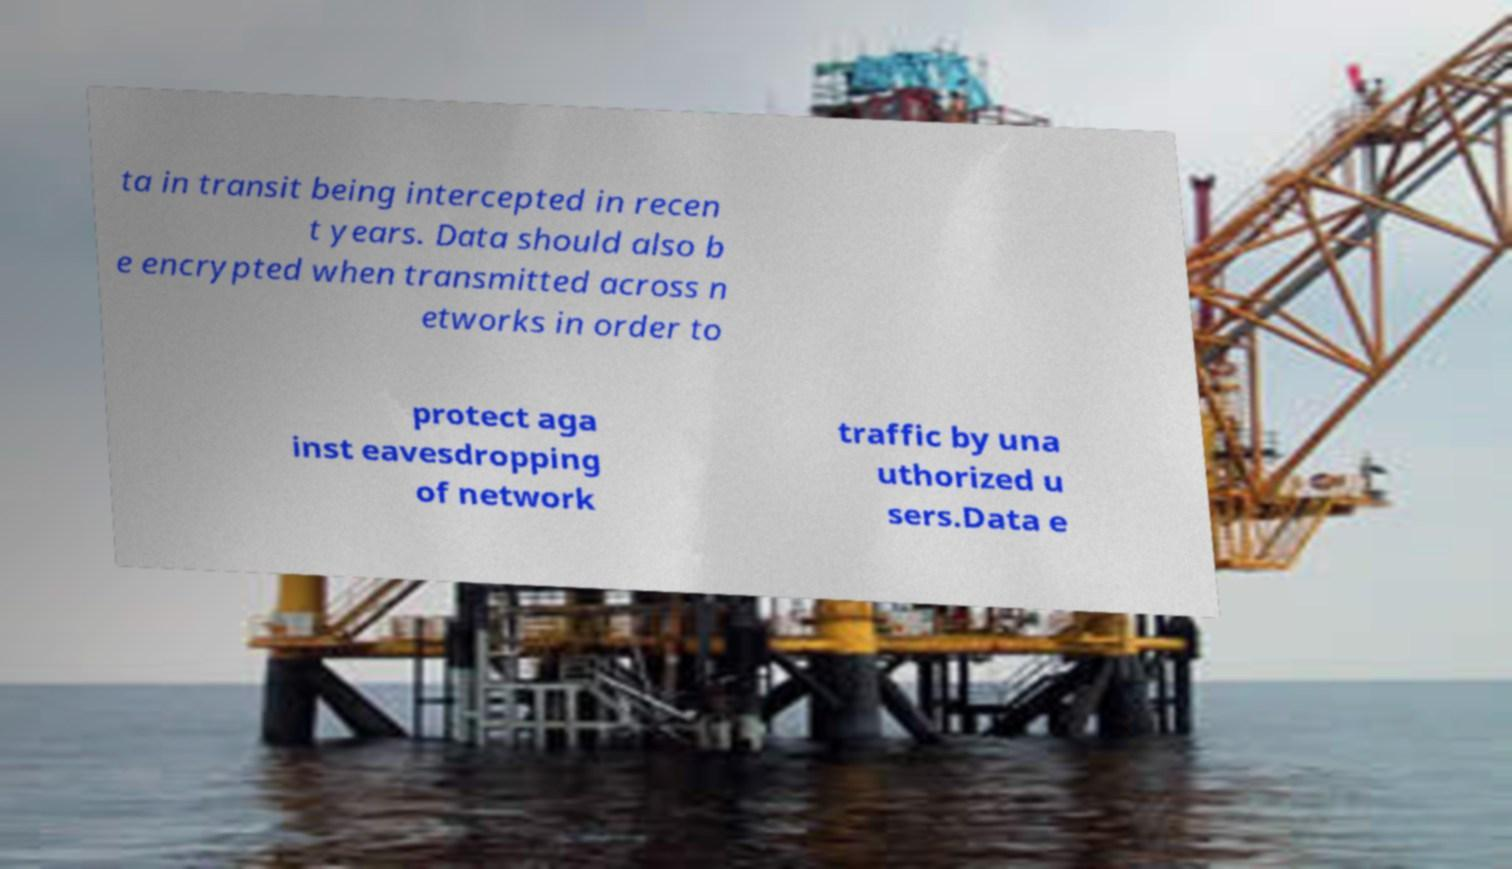Please identify and transcribe the text found in this image. ta in transit being intercepted in recen t years. Data should also b e encrypted when transmitted across n etworks in order to protect aga inst eavesdropping of network traffic by una uthorized u sers.Data e 